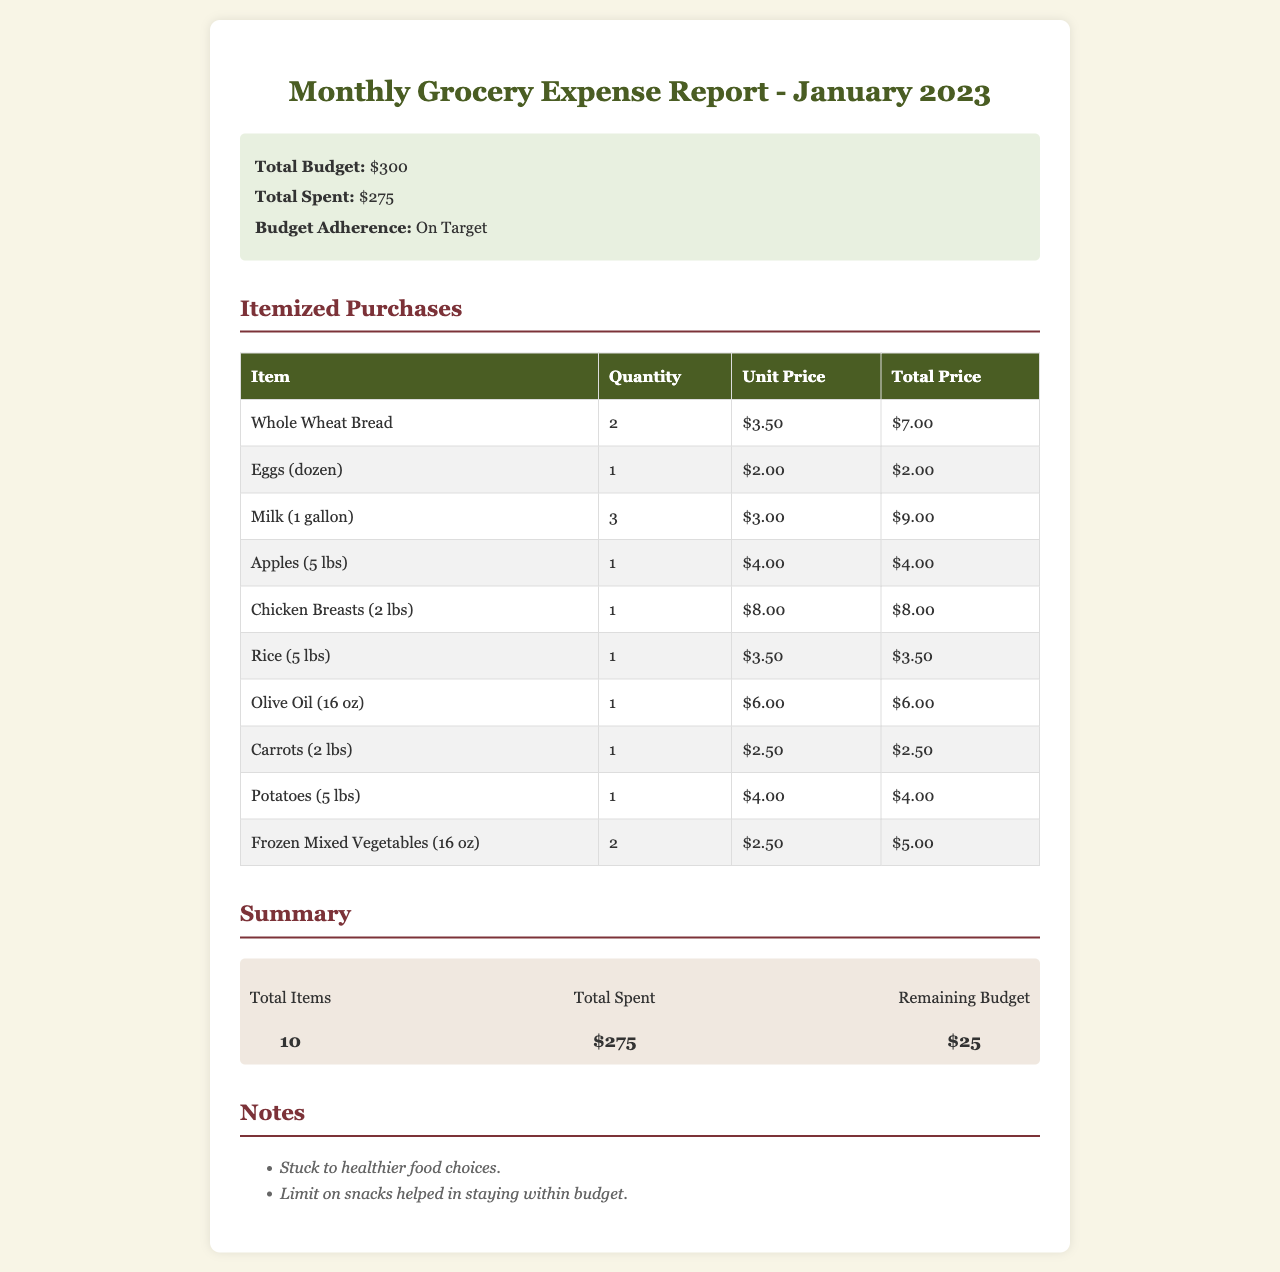What is the total budget for January 2023? The total budget is stated clearly in the summary section of the report.
Answer: $300 What was the total amount spent on groceries? The total spent is found in the summary section, reflecting the overall grocery expenses.
Answer: $275 How many items were purchased in total? The total items is indicated in the summary section, detailing the number of unique purchases made.
Answer: 10 What is the amount of the remaining budget? The remaining budget is listed in the summary and indicates how much is left after expenses.
Answer: $25 What is the unit price of whole wheat bread? The unit price of whole wheat bread is included in the itemized purchases table.
Answer: $3.50 Which item had the highest total price? The item with the highest total price can be determined by examining the total price column in the table.
Answer: Chicken Breasts (2 lbs) Was the budget adherence on target, above, or below? Budget adherence is summarized in the overview of the report, indicating whether it was achieved or not.
Answer: On Target What food choices were emphasized according to the notes? The notes indicate a specific focus on food choices highlighted in the budget report.
Answer: Healthier food choices Which item was purchased in the largest quantity? The item with the largest quantity is reflected in the itemized purchases table, showing its count.
Answer: Milk (1 gallon) 